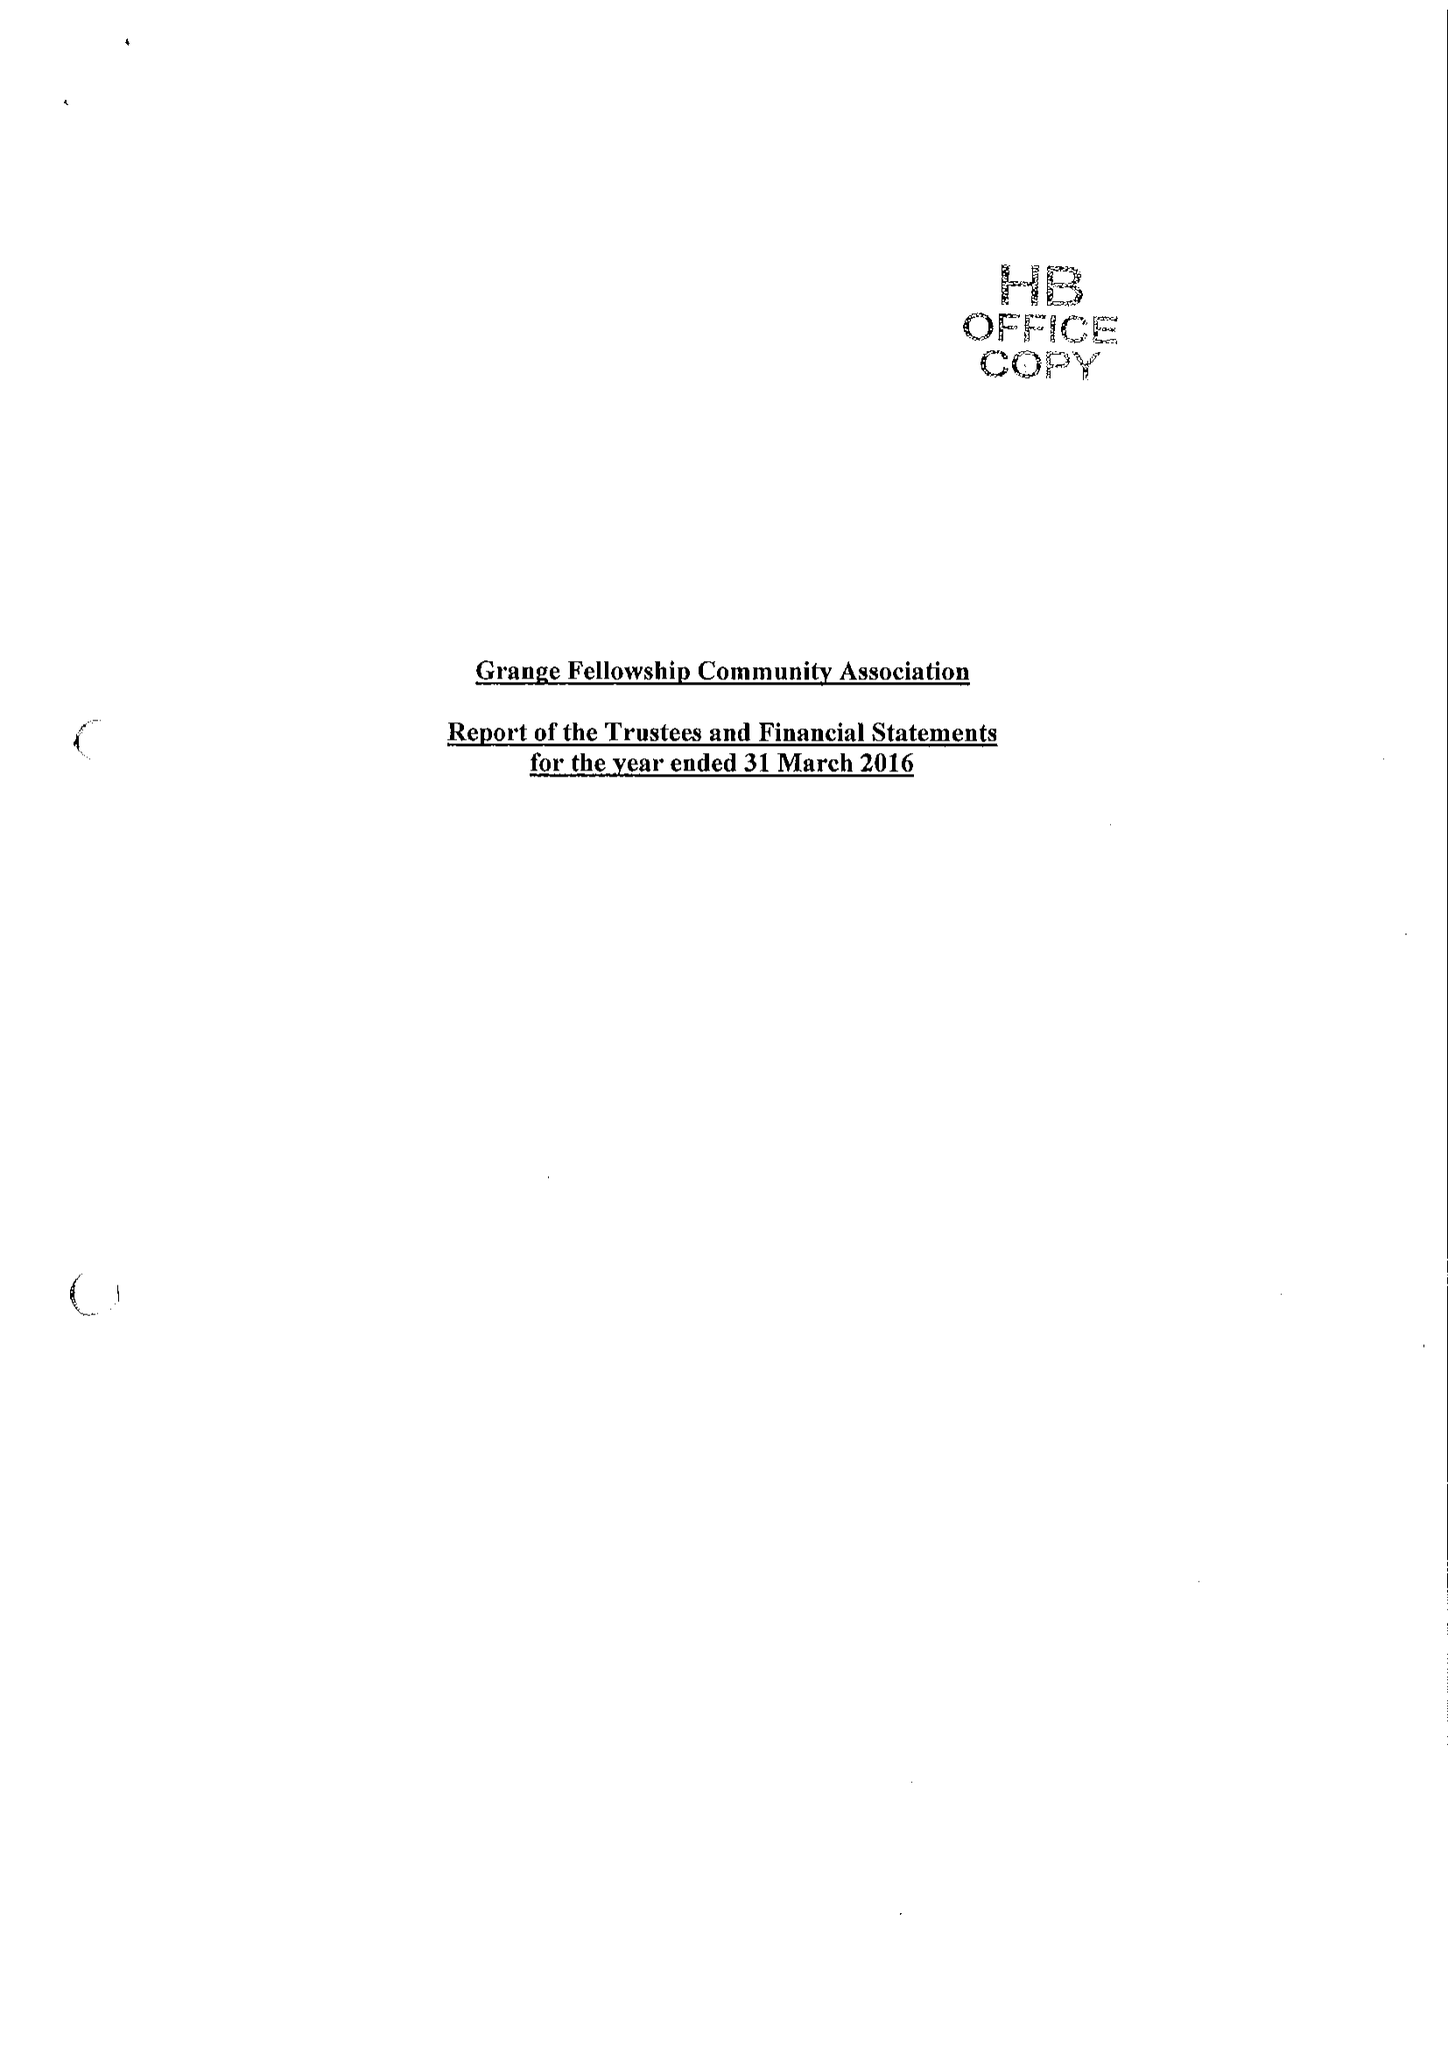What is the value for the income_annually_in_british_pounds?
Answer the question using a single word or phrase. 493358.00 